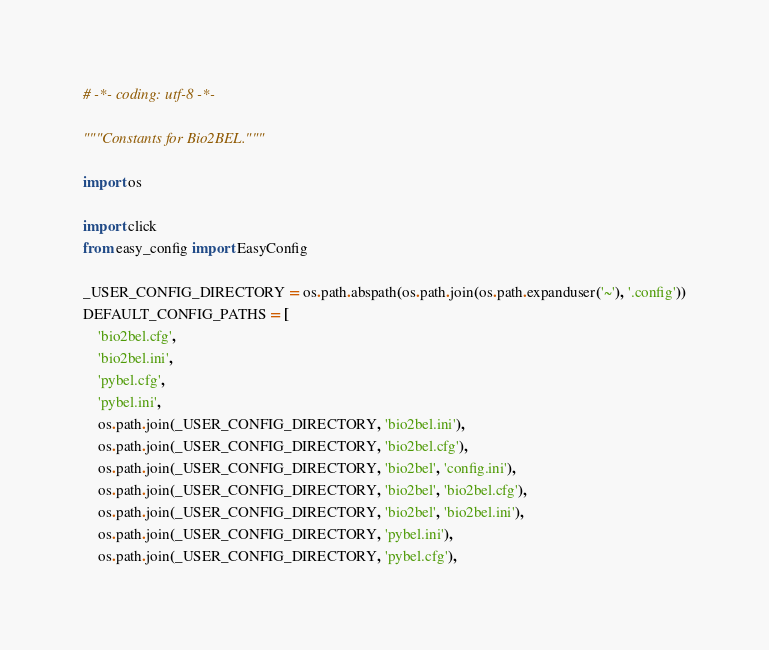<code> <loc_0><loc_0><loc_500><loc_500><_Python_># -*- coding: utf-8 -*-

"""Constants for Bio2BEL."""

import os

import click
from easy_config import EasyConfig

_USER_CONFIG_DIRECTORY = os.path.abspath(os.path.join(os.path.expanduser('~'), '.config'))
DEFAULT_CONFIG_PATHS = [
    'bio2bel.cfg',
    'bio2bel.ini',
    'pybel.cfg',
    'pybel.ini',
    os.path.join(_USER_CONFIG_DIRECTORY, 'bio2bel.ini'),
    os.path.join(_USER_CONFIG_DIRECTORY, 'bio2bel.cfg'),
    os.path.join(_USER_CONFIG_DIRECTORY, 'bio2bel', 'config.ini'),
    os.path.join(_USER_CONFIG_DIRECTORY, 'bio2bel', 'bio2bel.cfg'),
    os.path.join(_USER_CONFIG_DIRECTORY, 'bio2bel', 'bio2bel.ini'),
    os.path.join(_USER_CONFIG_DIRECTORY, 'pybel.ini'),
    os.path.join(_USER_CONFIG_DIRECTORY, 'pybel.cfg'),</code> 